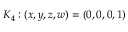<formula> <loc_0><loc_0><loc_500><loc_500>K _ { 4 } \colon ( x , y , z , w ) = ( 0 , 0 , 0 , 1 )</formula> 